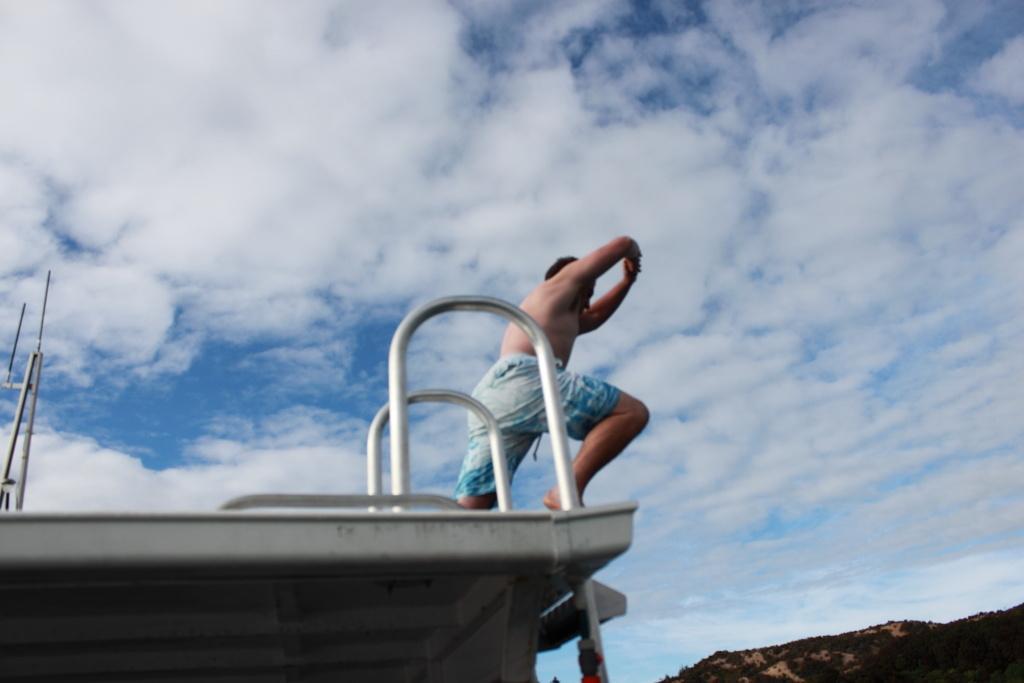Describe this image in one or two sentences. In this image there is a person standing on the metal platform. There are metal rods attached to the platform. On the right side of the image there are mountains. In the background of the image there is sky. 